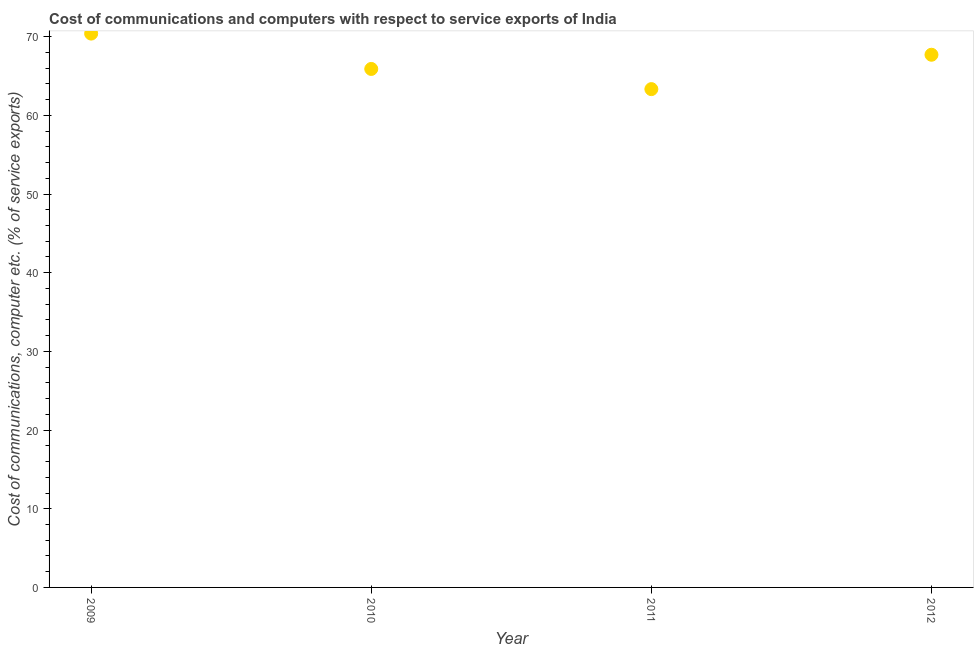What is the cost of communications and computer in 2011?
Make the answer very short. 63.34. Across all years, what is the maximum cost of communications and computer?
Provide a short and direct response. 70.39. Across all years, what is the minimum cost of communications and computer?
Keep it short and to the point. 63.34. In which year was the cost of communications and computer maximum?
Offer a terse response. 2009. In which year was the cost of communications and computer minimum?
Ensure brevity in your answer.  2011. What is the sum of the cost of communications and computer?
Give a very brief answer. 267.34. What is the difference between the cost of communications and computer in 2011 and 2012?
Offer a terse response. -4.37. What is the average cost of communications and computer per year?
Your answer should be very brief. 66.84. What is the median cost of communications and computer?
Keep it short and to the point. 66.8. In how many years, is the cost of communications and computer greater than 32 %?
Give a very brief answer. 4. What is the ratio of the cost of communications and computer in 2011 to that in 2012?
Offer a terse response. 0.94. Is the cost of communications and computer in 2009 less than that in 2011?
Provide a short and direct response. No. Is the difference between the cost of communications and computer in 2009 and 2010 greater than the difference between any two years?
Your response must be concise. No. What is the difference between the highest and the second highest cost of communications and computer?
Offer a very short reply. 2.69. What is the difference between the highest and the lowest cost of communications and computer?
Provide a short and direct response. 7.06. Does the cost of communications and computer monotonically increase over the years?
Your answer should be very brief. No. How many years are there in the graph?
Your answer should be compact. 4. What is the difference between two consecutive major ticks on the Y-axis?
Offer a very short reply. 10. Are the values on the major ticks of Y-axis written in scientific E-notation?
Your answer should be compact. No. Does the graph contain grids?
Provide a succinct answer. No. What is the title of the graph?
Make the answer very short. Cost of communications and computers with respect to service exports of India. What is the label or title of the X-axis?
Offer a very short reply. Year. What is the label or title of the Y-axis?
Offer a terse response. Cost of communications, computer etc. (% of service exports). What is the Cost of communications, computer etc. (% of service exports) in 2009?
Provide a short and direct response. 70.39. What is the Cost of communications, computer etc. (% of service exports) in 2010?
Give a very brief answer. 65.9. What is the Cost of communications, computer etc. (% of service exports) in 2011?
Make the answer very short. 63.34. What is the Cost of communications, computer etc. (% of service exports) in 2012?
Provide a short and direct response. 67.71. What is the difference between the Cost of communications, computer etc. (% of service exports) in 2009 and 2010?
Provide a short and direct response. 4.49. What is the difference between the Cost of communications, computer etc. (% of service exports) in 2009 and 2011?
Ensure brevity in your answer.  7.06. What is the difference between the Cost of communications, computer etc. (% of service exports) in 2009 and 2012?
Give a very brief answer. 2.69. What is the difference between the Cost of communications, computer etc. (% of service exports) in 2010 and 2011?
Offer a terse response. 2.56. What is the difference between the Cost of communications, computer etc. (% of service exports) in 2010 and 2012?
Offer a terse response. -1.8. What is the difference between the Cost of communications, computer etc. (% of service exports) in 2011 and 2012?
Offer a very short reply. -4.37. What is the ratio of the Cost of communications, computer etc. (% of service exports) in 2009 to that in 2010?
Provide a short and direct response. 1.07. What is the ratio of the Cost of communications, computer etc. (% of service exports) in 2009 to that in 2011?
Provide a succinct answer. 1.11. What is the ratio of the Cost of communications, computer etc. (% of service exports) in 2009 to that in 2012?
Provide a succinct answer. 1.04. What is the ratio of the Cost of communications, computer etc. (% of service exports) in 2011 to that in 2012?
Ensure brevity in your answer.  0.94. 